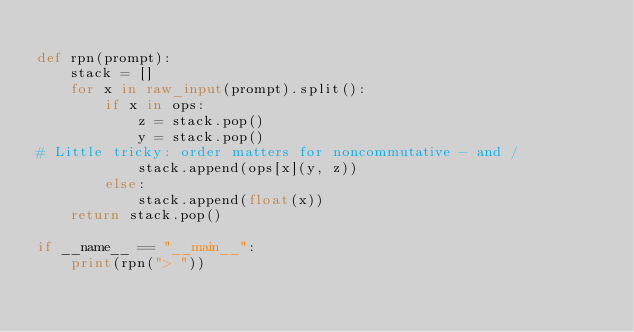<code> <loc_0><loc_0><loc_500><loc_500><_Python_>
def rpn(prompt):
    stack = []
    for x in raw_input(prompt).split():
        if x in ops:
            z = stack.pop()
            y = stack.pop()
# Little tricky: order matters for noncommutative - and /
            stack.append(ops[x](y, z))
        else:
            stack.append(float(x))
    return stack.pop()

if __name__ == "__main__":
    print(rpn("> "))
</code> 